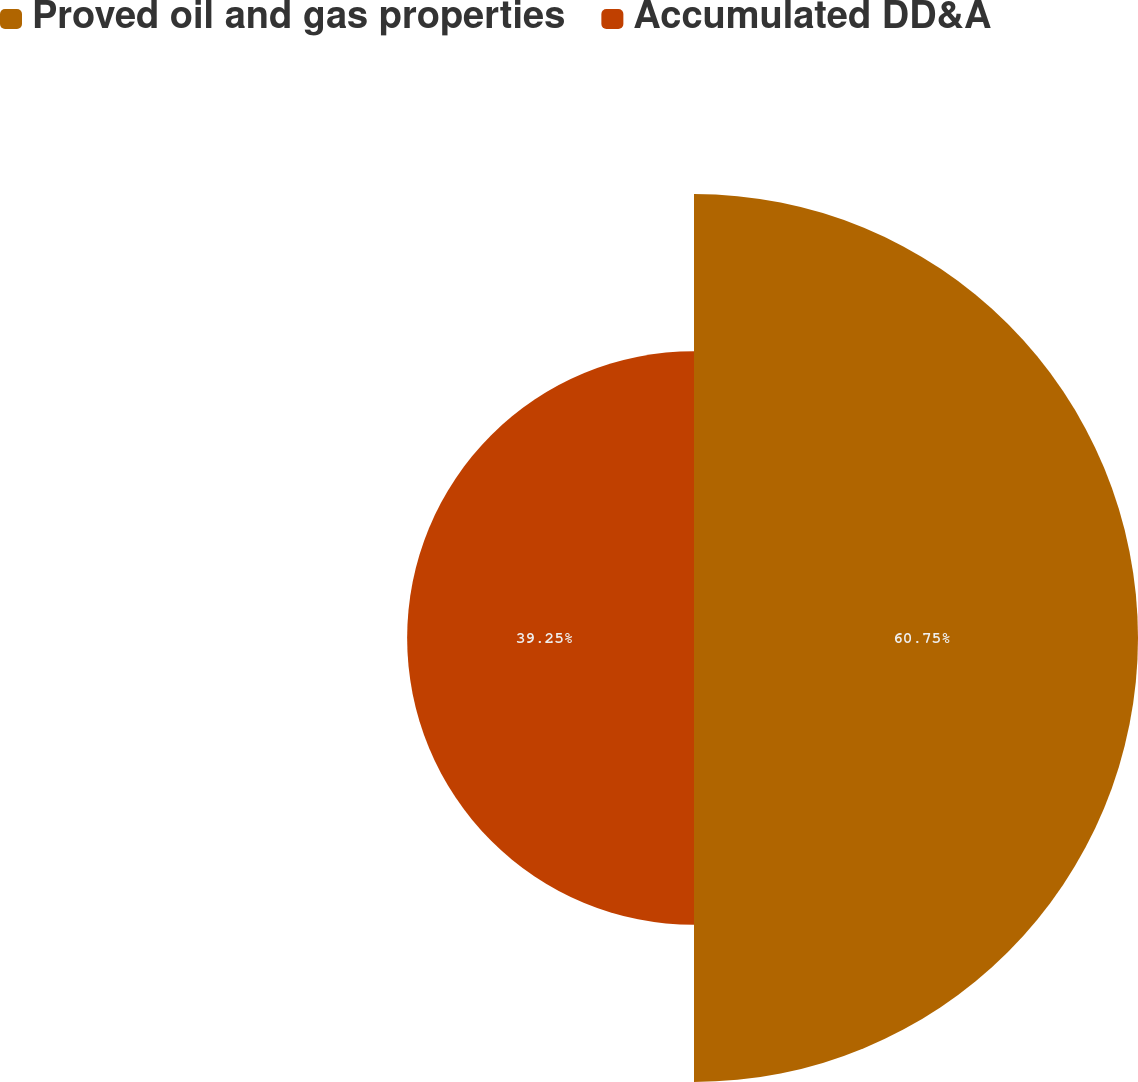Convert chart. <chart><loc_0><loc_0><loc_500><loc_500><pie_chart><fcel>Proved oil and gas properties<fcel>Accumulated DD&A<nl><fcel>60.75%<fcel>39.25%<nl></chart> 